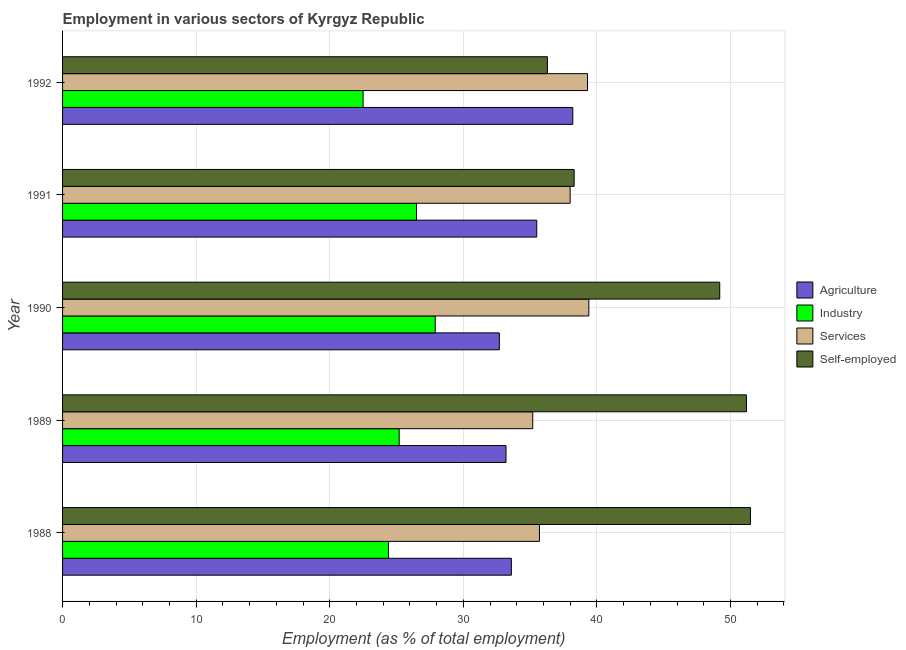Are the number of bars per tick equal to the number of legend labels?
Keep it short and to the point. Yes. How many bars are there on the 5th tick from the top?
Make the answer very short. 4. What is the label of the 1st group of bars from the top?
Keep it short and to the point. 1992. In how many cases, is the number of bars for a given year not equal to the number of legend labels?
Provide a short and direct response. 0. What is the percentage of workers in agriculture in 1989?
Offer a terse response. 33.2. Across all years, what is the maximum percentage of self employed workers?
Ensure brevity in your answer.  51.5. Across all years, what is the minimum percentage of workers in industry?
Provide a succinct answer. 22.5. In which year was the percentage of workers in services maximum?
Your answer should be compact. 1990. What is the total percentage of workers in industry in the graph?
Keep it short and to the point. 126.5. What is the difference between the percentage of self employed workers in 1989 and that in 1992?
Make the answer very short. 14.9. What is the difference between the percentage of workers in services in 1990 and the percentage of workers in industry in 1991?
Your response must be concise. 12.9. What is the average percentage of workers in agriculture per year?
Your answer should be compact. 34.64. In the year 1992, what is the difference between the percentage of workers in industry and percentage of workers in agriculture?
Your response must be concise. -15.7. In how many years, is the percentage of workers in services greater than 52 %?
Ensure brevity in your answer.  0. What is the ratio of the percentage of workers in industry in 1988 to that in 1990?
Provide a succinct answer. 0.88. Is the difference between the percentage of workers in agriculture in 1988 and 1992 greater than the difference between the percentage of workers in industry in 1988 and 1992?
Your answer should be compact. No. What is the difference between the highest and the second highest percentage of workers in services?
Offer a very short reply. 0.1. What is the difference between the highest and the lowest percentage of workers in agriculture?
Ensure brevity in your answer.  5.5. In how many years, is the percentage of workers in services greater than the average percentage of workers in services taken over all years?
Offer a terse response. 3. What does the 3rd bar from the top in 1991 represents?
Your answer should be compact. Industry. What does the 4th bar from the bottom in 1989 represents?
Your answer should be very brief. Self-employed. How many years are there in the graph?
Your answer should be compact. 5. What is the difference between two consecutive major ticks on the X-axis?
Ensure brevity in your answer.  10. Are the values on the major ticks of X-axis written in scientific E-notation?
Make the answer very short. No. Where does the legend appear in the graph?
Give a very brief answer. Center right. How are the legend labels stacked?
Provide a succinct answer. Vertical. What is the title of the graph?
Your answer should be compact. Employment in various sectors of Kyrgyz Republic. What is the label or title of the X-axis?
Your response must be concise. Employment (as % of total employment). What is the Employment (as % of total employment) in Agriculture in 1988?
Provide a succinct answer. 33.6. What is the Employment (as % of total employment) in Industry in 1988?
Provide a short and direct response. 24.4. What is the Employment (as % of total employment) of Services in 1988?
Offer a terse response. 35.7. What is the Employment (as % of total employment) in Self-employed in 1988?
Make the answer very short. 51.5. What is the Employment (as % of total employment) in Agriculture in 1989?
Keep it short and to the point. 33.2. What is the Employment (as % of total employment) of Industry in 1989?
Give a very brief answer. 25.2. What is the Employment (as % of total employment) in Services in 1989?
Make the answer very short. 35.2. What is the Employment (as % of total employment) of Self-employed in 1989?
Keep it short and to the point. 51.2. What is the Employment (as % of total employment) of Agriculture in 1990?
Your response must be concise. 32.7. What is the Employment (as % of total employment) of Industry in 1990?
Your answer should be very brief. 27.9. What is the Employment (as % of total employment) of Services in 1990?
Your answer should be compact. 39.4. What is the Employment (as % of total employment) in Self-employed in 1990?
Your response must be concise. 49.2. What is the Employment (as % of total employment) in Agriculture in 1991?
Your answer should be very brief. 35.5. What is the Employment (as % of total employment) of Industry in 1991?
Your response must be concise. 26.5. What is the Employment (as % of total employment) of Self-employed in 1991?
Your answer should be very brief. 38.3. What is the Employment (as % of total employment) of Agriculture in 1992?
Keep it short and to the point. 38.2. What is the Employment (as % of total employment) of Services in 1992?
Offer a terse response. 39.3. What is the Employment (as % of total employment) of Self-employed in 1992?
Provide a short and direct response. 36.3. Across all years, what is the maximum Employment (as % of total employment) in Agriculture?
Keep it short and to the point. 38.2. Across all years, what is the maximum Employment (as % of total employment) in Industry?
Offer a terse response. 27.9. Across all years, what is the maximum Employment (as % of total employment) of Services?
Your answer should be very brief. 39.4. Across all years, what is the maximum Employment (as % of total employment) in Self-employed?
Provide a succinct answer. 51.5. Across all years, what is the minimum Employment (as % of total employment) in Agriculture?
Provide a succinct answer. 32.7. Across all years, what is the minimum Employment (as % of total employment) of Services?
Your response must be concise. 35.2. Across all years, what is the minimum Employment (as % of total employment) of Self-employed?
Make the answer very short. 36.3. What is the total Employment (as % of total employment) of Agriculture in the graph?
Provide a succinct answer. 173.2. What is the total Employment (as % of total employment) in Industry in the graph?
Your response must be concise. 126.5. What is the total Employment (as % of total employment) of Services in the graph?
Your answer should be compact. 187.6. What is the total Employment (as % of total employment) of Self-employed in the graph?
Offer a very short reply. 226.5. What is the difference between the Employment (as % of total employment) in Agriculture in 1988 and that in 1989?
Provide a short and direct response. 0.4. What is the difference between the Employment (as % of total employment) of Services in 1988 and that in 1989?
Offer a very short reply. 0.5. What is the difference between the Employment (as % of total employment) of Agriculture in 1988 and that in 1990?
Make the answer very short. 0.9. What is the difference between the Employment (as % of total employment) in Self-employed in 1988 and that in 1990?
Provide a succinct answer. 2.3. What is the difference between the Employment (as % of total employment) in Agriculture in 1988 and that in 1991?
Keep it short and to the point. -1.9. What is the difference between the Employment (as % of total employment) of Self-employed in 1988 and that in 1991?
Provide a short and direct response. 13.2. What is the difference between the Employment (as % of total employment) in Industry in 1988 and that in 1992?
Make the answer very short. 1.9. What is the difference between the Employment (as % of total employment) of Agriculture in 1989 and that in 1990?
Offer a terse response. 0.5. What is the difference between the Employment (as % of total employment) in Agriculture in 1989 and that in 1991?
Your response must be concise. -2.3. What is the difference between the Employment (as % of total employment) in Services in 1989 and that in 1991?
Offer a very short reply. -2.8. What is the difference between the Employment (as % of total employment) of Self-employed in 1989 and that in 1991?
Give a very brief answer. 12.9. What is the difference between the Employment (as % of total employment) of Agriculture in 1989 and that in 1992?
Ensure brevity in your answer.  -5. What is the difference between the Employment (as % of total employment) of Self-employed in 1989 and that in 1992?
Provide a short and direct response. 14.9. What is the difference between the Employment (as % of total employment) of Agriculture in 1990 and that in 1991?
Your response must be concise. -2.8. What is the difference between the Employment (as % of total employment) of Services in 1990 and that in 1991?
Offer a terse response. 1.4. What is the difference between the Employment (as % of total employment) of Industry in 1990 and that in 1992?
Make the answer very short. 5.4. What is the difference between the Employment (as % of total employment) in Services in 1990 and that in 1992?
Your answer should be very brief. 0.1. What is the difference between the Employment (as % of total employment) in Self-employed in 1990 and that in 1992?
Your response must be concise. 12.9. What is the difference between the Employment (as % of total employment) in Agriculture in 1991 and that in 1992?
Keep it short and to the point. -2.7. What is the difference between the Employment (as % of total employment) of Self-employed in 1991 and that in 1992?
Provide a short and direct response. 2. What is the difference between the Employment (as % of total employment) in Agriculture in 1988 and the Employment (as % of total employment) in Industry in 1989?
Make the answer very short. 8.4. What is the difference between the Employment (as % of total employment) in Agriculture in 1988 and the Employment (as % of total employment) in Self-employed in 1989?
Offer a terse response. -17.6. What is the difference between the Employment (as % of total employment) in Industry in 1988 and the Employment (as % of total employment) in Services in 1989?
Keep it short and to the point. -10.8. What is the difference between the Employment (as % of total employment) of Industry in 1988 and the Employment (as % of total employment) of Self-employed in 1989?
Ensure brevity in your answer.  -26.8. What is the difference between the Employment (as % of total employment) of Services in 1988 and the Employment (as % of total employment) of Self-employed in 1989?
Give a very brief answer. -15.5. What is the difference between the Employment (as % of total employment) in Agriculture in 1988 and the Employment (as % of total employment) in Services in 1990?
Provide a short and direct response. -5.8. What is the difference between the Employment (as % of total employment) in Agriculture in 1988 and the Employment (as % of total employment) in Self-employed in 1990?
Your response must be concise. -15.6. What is the difference between the Employment (as % of total employment) of Industry in 1988 and the Employment (as % of total employment) of Self-employed in 1990?
Offer a terse response. -24.8. What is the difference between the Employment (as % of total employment) in Agriculture in 1988 and the Employment (as % of total employment) in Services in 1991?
Your answer should be very brief. -4.4. What is the difference between the Employment (as % of total employment) in Agriculture in 1988 and the Employment (as % of total employment) in Industry in 1992?
Provide a succinct answer. 11.1. What is the difference between the Employment (as % of total employment) in Agriculture in 1988 and the Employment (as % of total employment) in Services in 1992?
Your response must be concise. -5.7. What is the difference between the Employment (as % of total employment) in Agriculture in 1988 and the Employment (as % of total employment) in Self-employed in 1992?
Your answer should be very brief. -2.7. What is the difference between the Employment (as % of total employment) of Industry in 1988 and the Employment (as % of total employment) of Services in 1992?
Your answer should be very brief. -14.9. What is the difference between the Employment (as % of total employment) in Agriculture in 1989 and the Employment (as % of total employment) in Industry in 1990?
Your answer should be compact. 5.3. What is the difference between the Employment (as % of total employment) in Agriculture in 1989 and the Employment (as % of total employment) in Services in 1990?
Make the answer very short. -6.2. What is the difference between the Employment (as % of total employment) of Industry in 1989 and the Employment (as % of total employment) of Services in 1990?
Keep it short and to the point. -14.2. What is the difference between the Employment (as % of total employment) in Industry in 1989 and the Employment (as % of total employment) in Self-employed in 1990?
Give a very brief answer. -24. What is the difference between the Employment (as % of total employment) of Agriculture in 1989 and the Employment (as % of total employment) of Services in 1991?
Ensure brevity in your answer.  -4.8. What is the difference between the Employment (as % of total employment) of Industry in 1989 and the Employment (as % of total employment) of Services in 1991?
Provide a succinct answer. -12.8. What is the difference between the Employment (as % of total employment) of Services in 1989 and the Employment (as % of total employment) of Self-employed in 1991?
Keep it short and to the point. -3.1. What is the difference between the Employment (as % of total employment) of Agriculture in 1989 and the Employment (as % of total employment) of Services in 1992?
Provide a short and direct response. -6.1. What is the difference between the Employment (as % of total employment) in Agriculture in 1989 and the Employment (as % of total employment) in Self-employed in 1992?
Your answer should be very brief. -3.1. What is the difference between the Employment (as % of total employment) of Industry in 1989 and the Employment (as % of total employment) of Services in 1992?
Your answer should be very brief. -14.1. What is the difference between the Employment (as % of total employment) of Services in 1990 and the Employment (as % of total employment) of Self-employed in 1991?
Offer a very short reply. 1.1. What is the difference between the Employment (as % of total employment) of Agriculture in 1990 and the Employment (as % of total employment) of Services in 1992?
Ensure brevity in your answer.  -6.6. What is the difference between the Employment (as % of total employment) of Services in 1990 and the Employment (as % of total employment) of Self-employed in 1992?
Your answer should be compact. 3.1. What is the difference between the Employment (as % of total employment) of Agriculture in 1991 and the Employment (as % of total employment) of Services in 1992?
Ensure brevity in your answer.  -3.8. What is the difference between the Employment (as % of total employment) of Agriculture in 1991 and the Employment (as % of total employment) of Self-employed in 1992?
Your answer should be very brief. -0.8. What is the difference between the Employment (as % of total employment) of Services in 1991 and the Employment (as % of total employment) of Self-employed in 1992?
Keep it short and to the point. 1.7. What is the average Employment (as % of total employment) in Agriculture per year?
Offer a terse response. 34.64. What is the average Employment (as % of total employment) of Industry per year?
Provide a succinct answer. 25.3. What is the average Employment (as % of total employment) of Services per year?
Provide a succinct answer. 37.52. What is the average Employment (as % of total employment) in Self-employed per year?
Your answer should be very brief. 45.3. In the year 1988, what is the difference between the Employment (as % of total employment) in Agriculture and Employment (as % of total employment) in Services?
Give a very brief answer. -2.1. In the year 1988, what is the difference between the Employment (as % of total employment) in Agriculture and Employment (as % of total employment) in Self-employed?
Your answer should be very brief. -17.9. In the year 1988, what is the difference between the Employment (as % of total employment) of Industry and Employment (as % of total employment) of Self-employed?
Provide a succinct answer. -27.1. In the year 1988, what is the difference between the Employment (as % of total employment) in Services and Employment (as % of total employment) in Self-employed?
Your answer should be very brief. -15.8. In the year 1989, what is the difference between the Employment (as % of total employment) of Agriculture and Employment (as % of total employment) of Industry?
Provide a short and direct response. 8. In the year 1989, what is the difference between the Employment (as % of total employment) in Agriculture and Employment (as % of total employment) in Self-employed?
Offer a very short reply. -18. In the year 1989, what is the difference between the Employment (as % of total employment) of Industry and Employment (as % of total employment) of Services?
Provide a short and direct response. -10. In the year 1990, what is the difference between the Employment (as % of total employment) in Agriculture and Employment (as % of total employment) in Industry?
Make the answer very short. 4.8. In the year 1990, what is the difference between the Employment (as % of total employment) in Agriculture and Employment (as % of total employment) in Self-employed?
Provide a succinct answer. -16.5. In the year 1990, what is the difference between the Employment (as % of total employment) of Industry and Employment (as % of total employment) of Self-employed?
Your answer should be compact. -21.3. In the year 1991, what is the difference between the Employment (as % of total employment) of Agriculture and Employment (as % of total employment) of Industry?
Your answer should be compact. 9. In the year 1991, what is the difference between the Employment (as % of total employment) of Agriculture and Employment (as % of total employment) of Self-employed?
Give a very brief answer. -2.8. In the year 1991, what is the difference between the Employment (as % of total employment) of Industry and Employment (as % of total employment) of Services?
Ensure brevity in your answer.  -11.5. In the year 1991, what is the difference between the Employment (as % of total employment) of Industry and Employment (as % of total employment) of Self-employed?
Your response must be concise. -11.8. In the year 1991, what is the difference between the Employment (as % of total employment) in Services and Employment (as % of total employment) in Self-employed?
Your response must be concise. -0.3. In the year 1992, what is the difference between the Employment (as % of total employment) in Agriculture and Employment (as % of total employment) in Self-employed?
Ensure brevity in your answer.  1.9. In the year 1992, what is the difference between the Employment (as % of total employment) in Industry and Employment (as % of total employment) in Services?
Ensure brevity in your answer.  -16.8. What is the ratio of the Employment (as % of total employment) in Industry in 1988 to that in 1989?
Your answer should be very brief. 0.97. What is the ratio of the Employment (as % of total employment) in Services in 1988 to that in 1989?
Ensure brevity in your answer.  1.01. What is the ratio of the Employment (as % of total employment) of Self-employed in 1988 to that in 1989?
Your response must be concise. 1.01. What is the ratio of the Employment (as % of total employment) in Agriculture in 1988 to that in 1990?
Keep it short and to the point. 1.03. What is the ratio of the Employment (as % of total employment) of Industry in 1988 to that in 1990?
Keep it short and to the point. 0.87. What is the ratio of the Employment (as % of total employment) of Services in 1988 to that in 1990?
Provide a short and direct response. 0.91. What is the ratio of the Employment (as % of total employment) of Self-employed in 1988 to that in 1990?
Make the answer very short. 1.05. What is the ratio of the Employment (as % of total employment) of Agriculture in 1988 to that in 1991?
Provide a short and direct response. 0.95. What is the ratio of the Employment (as % of total employment) in Industry in 1988 to that in 1991?
Offer a very short reply. 0.92. What is the ratio of the Employment (as % of total employment) in Services in 1988 to that in 1991?
Provide a succinct answer. 0.94. What is the ratio of the Employment (as % of total employment) of Self-employed in 1988 to that in 1991?
Keep it short and to the point. 1.34. What is the ratio of the Employment (as % of total employment) in Agriculture in 1988 to that in 1992?
Your response must be concise. 0.88. What is the ratio of the Employment (as % of total employment) of Industry in 1988 to that in 1992?
Offer a terse response. 1.08. What is the ratio of the Employment (as % of total employment) of Services in 1988 to that in 1992?
Your answer should be very brief. 0.91. What is the ratio of the Employment (as % of total employment) in Self-employed in 1988 to that in 1992?
Your answer should be compact. 1.42. What is the ratio of the Employment (as % of total employment) in Agriculture in 1989 to that in 1990?
Provide a succinct answer. 1.02. What is the ratio of the Employment (as % of total employment) in Industry in 1989 to that in 1990?
Provide a succinct answer. 0.9. What is the ratio of the Employment (as % of total employment) of Services in 1989 to that in 1990?
Keep it short and to the point. 0.89. What is the ratio of the Employment (as % of total employment) of Self-employed in 1989 to that in 1990?
Offer a very short reply. 1.04. What is the ratio of the Employment (as % of total employment) of Agriculture in 1989 to that in 1991?
Ensure brevity in your answer.  0.94. What is the ratio of the Employment (as % of total employment) of Industry in 1989 to that in 1991?
Your answer should be very brief. 0.95. What is the ratio of the Employment (as % of total employment) of Services in 1989 to that in 1991?
Your answer should be very brief. 0.93. What is the ratio of the Employment (as % of total employment) in Self-employed in 1989 to that in 1991?
Your response must be concise. 1.34. What is the ratio of the Employment (as % of total employment) in Agriculture in 1989 to that in 1992?
Offer a terse response. 0.87. What is the ratio of the Employment (as % of total employment) of Industry in 1989 to that in 1992?
Offer a terse response. 1.12. What is the ratio of the Employment (as % of total employment) of Services in 1989 to that in 1992?
Provide a short and direct response. 0.9. What is the ratio of the Employment (as % of total employment) of Self-employed in 1989 to that in 1992?
Keep it short and to the point. 1.41. What is the ratio of the Employment (as % of total employment) in Agriculture in 1990 to that in 1991?
Your answer should be very brief. 0.92. What is the ratio of the Employment (as % of total employment) of Industry in 1990 to that in 1991?
Provide a succinct answer. 1.05. What is the ratio of the Employment (as % of total employment) of Services in 1990 to that in 1991?
Offer a terse response. 1.04. What is the ratio of the Employment (as % of total employment) of Self-employed in 1990 to that in 1991?
Give a very brief answer. 1.28. What is the ratio of the Employment (as % of total employment) of Agriculture in 1990 to that in 1992?
Keep it short and to the point. 0.86. What is the ratio of the Employment (as % of total employment) in Industry in 1990 to that in 1992?
Your answer should be very brief. 1.24. What is the ratio of the Employment (as % of total employment) of Services in 1990 to that in 1992?
Ensure brevity in your answer.  1. What is the ratio of the Employment (as % of total employment) of Self-employed in 1990 to that in 1992?
Provide a succinct answer. 1.36. What is the ratio of the Employment (as % of total employment) of Agriculture in 1991 to that in 1992?
Your answer should be very brief. 0.93. What is the ratio of the Employment (as % of total employment) of Industry in 1991 to that in 1992?
Ensure brevity in your answer.  1.18. What is the ratio of the Employment (as % of total employment) in Services in 1991 to that in 1992?
Provide a short and direct response. 0.97. What is the ratio of the Employment (as % of total employment) in Self-employed in 1991 to that in 1992?
Provide a succinct answer. 1.06. What is the difference between the highest and the second highest Employment (as % of total employment) of Self-employed?
Ensure brevity in your answer.  0.3. What is the difference between the highest and the lowest Employment (as % of total employment) in Agriculture?
Your response must be concise. 5.5. What is the difference between the highest and the lowest Employment (as % of total employment) of Self-employed?
Offer a terse response. 15.2. 